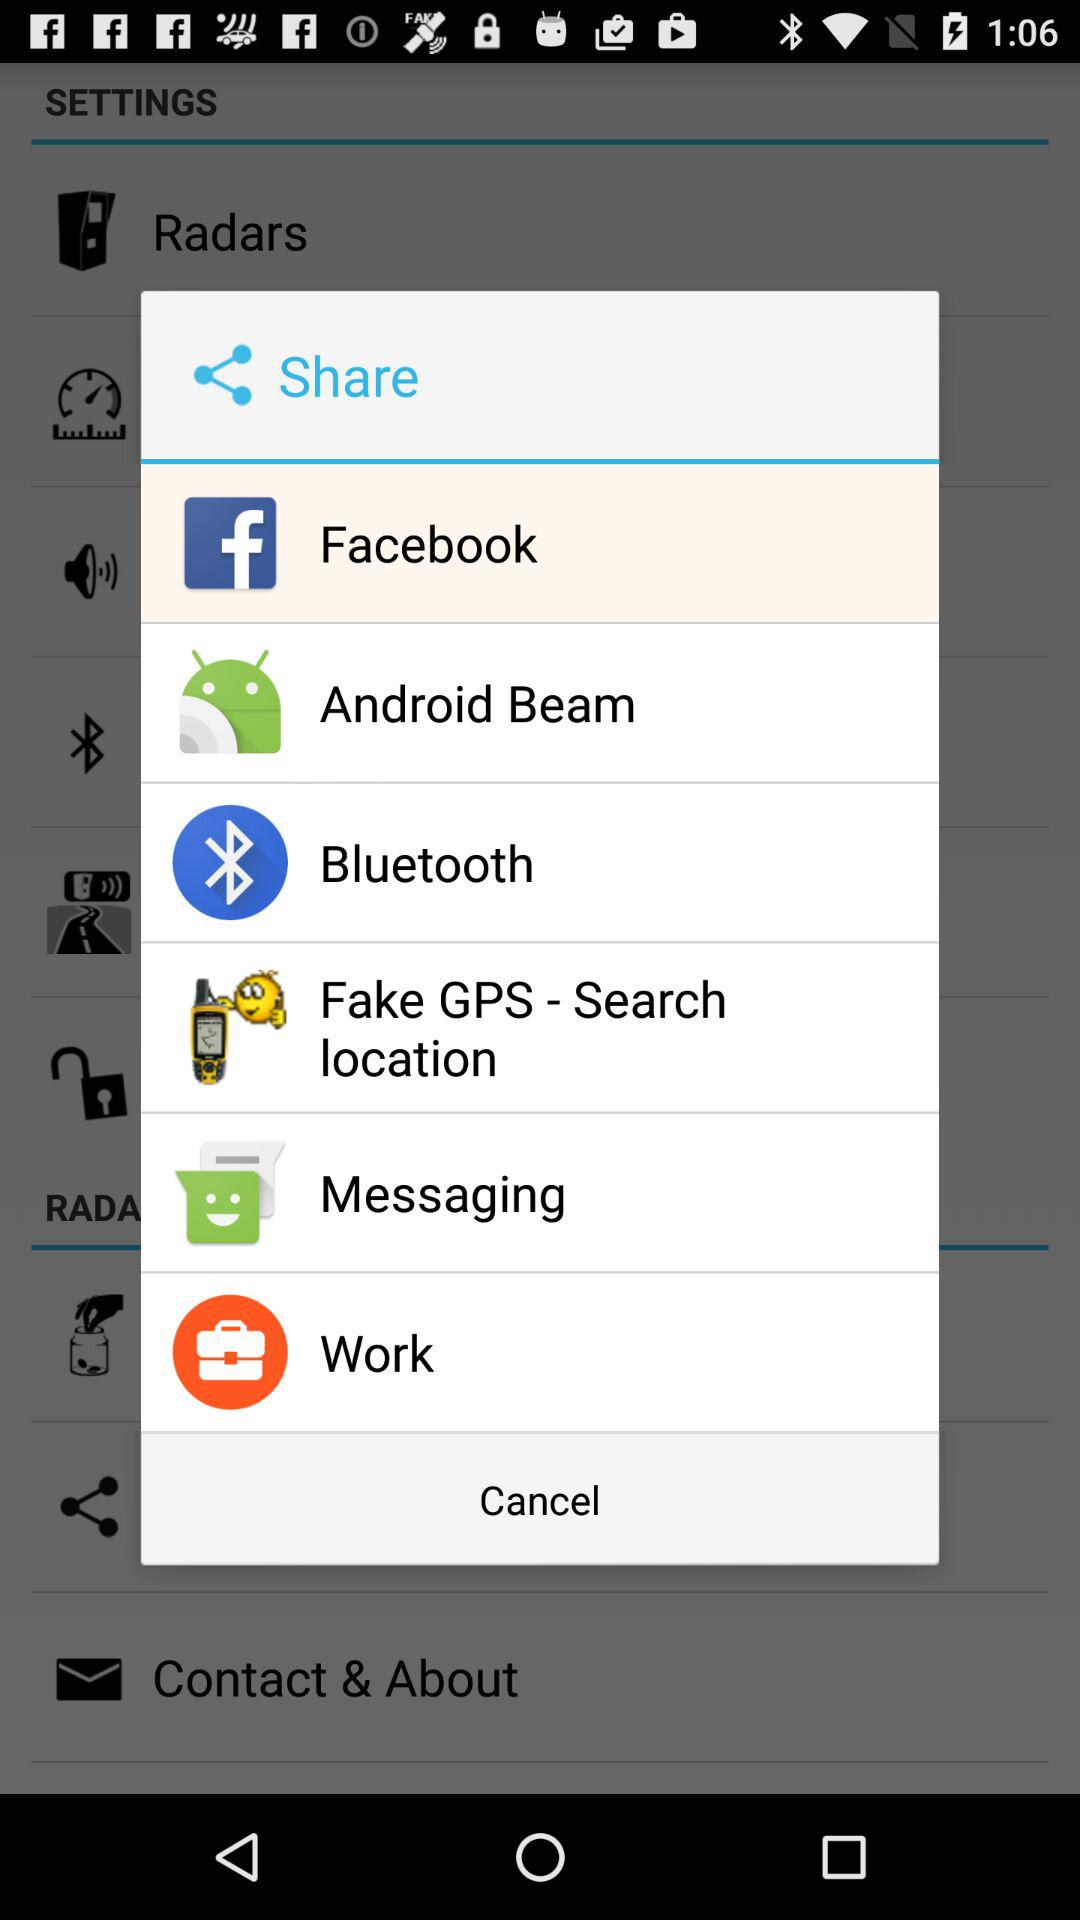What are the different options available for sharing? The different options available for sharing are "Facebook", "Android Beam", "Bluetooth", "Fake GPS - Search location", "Messaging" and "Work". 